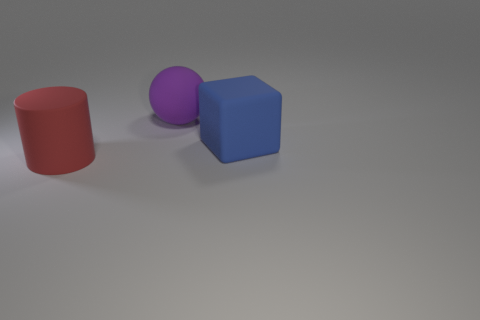Can you describe the shapes and colors of the objects shown? Certainly! The image displays three objects: a red cylinder, a purple sphere, and a blue cube. Each object has a distinct geometric shape and color. 